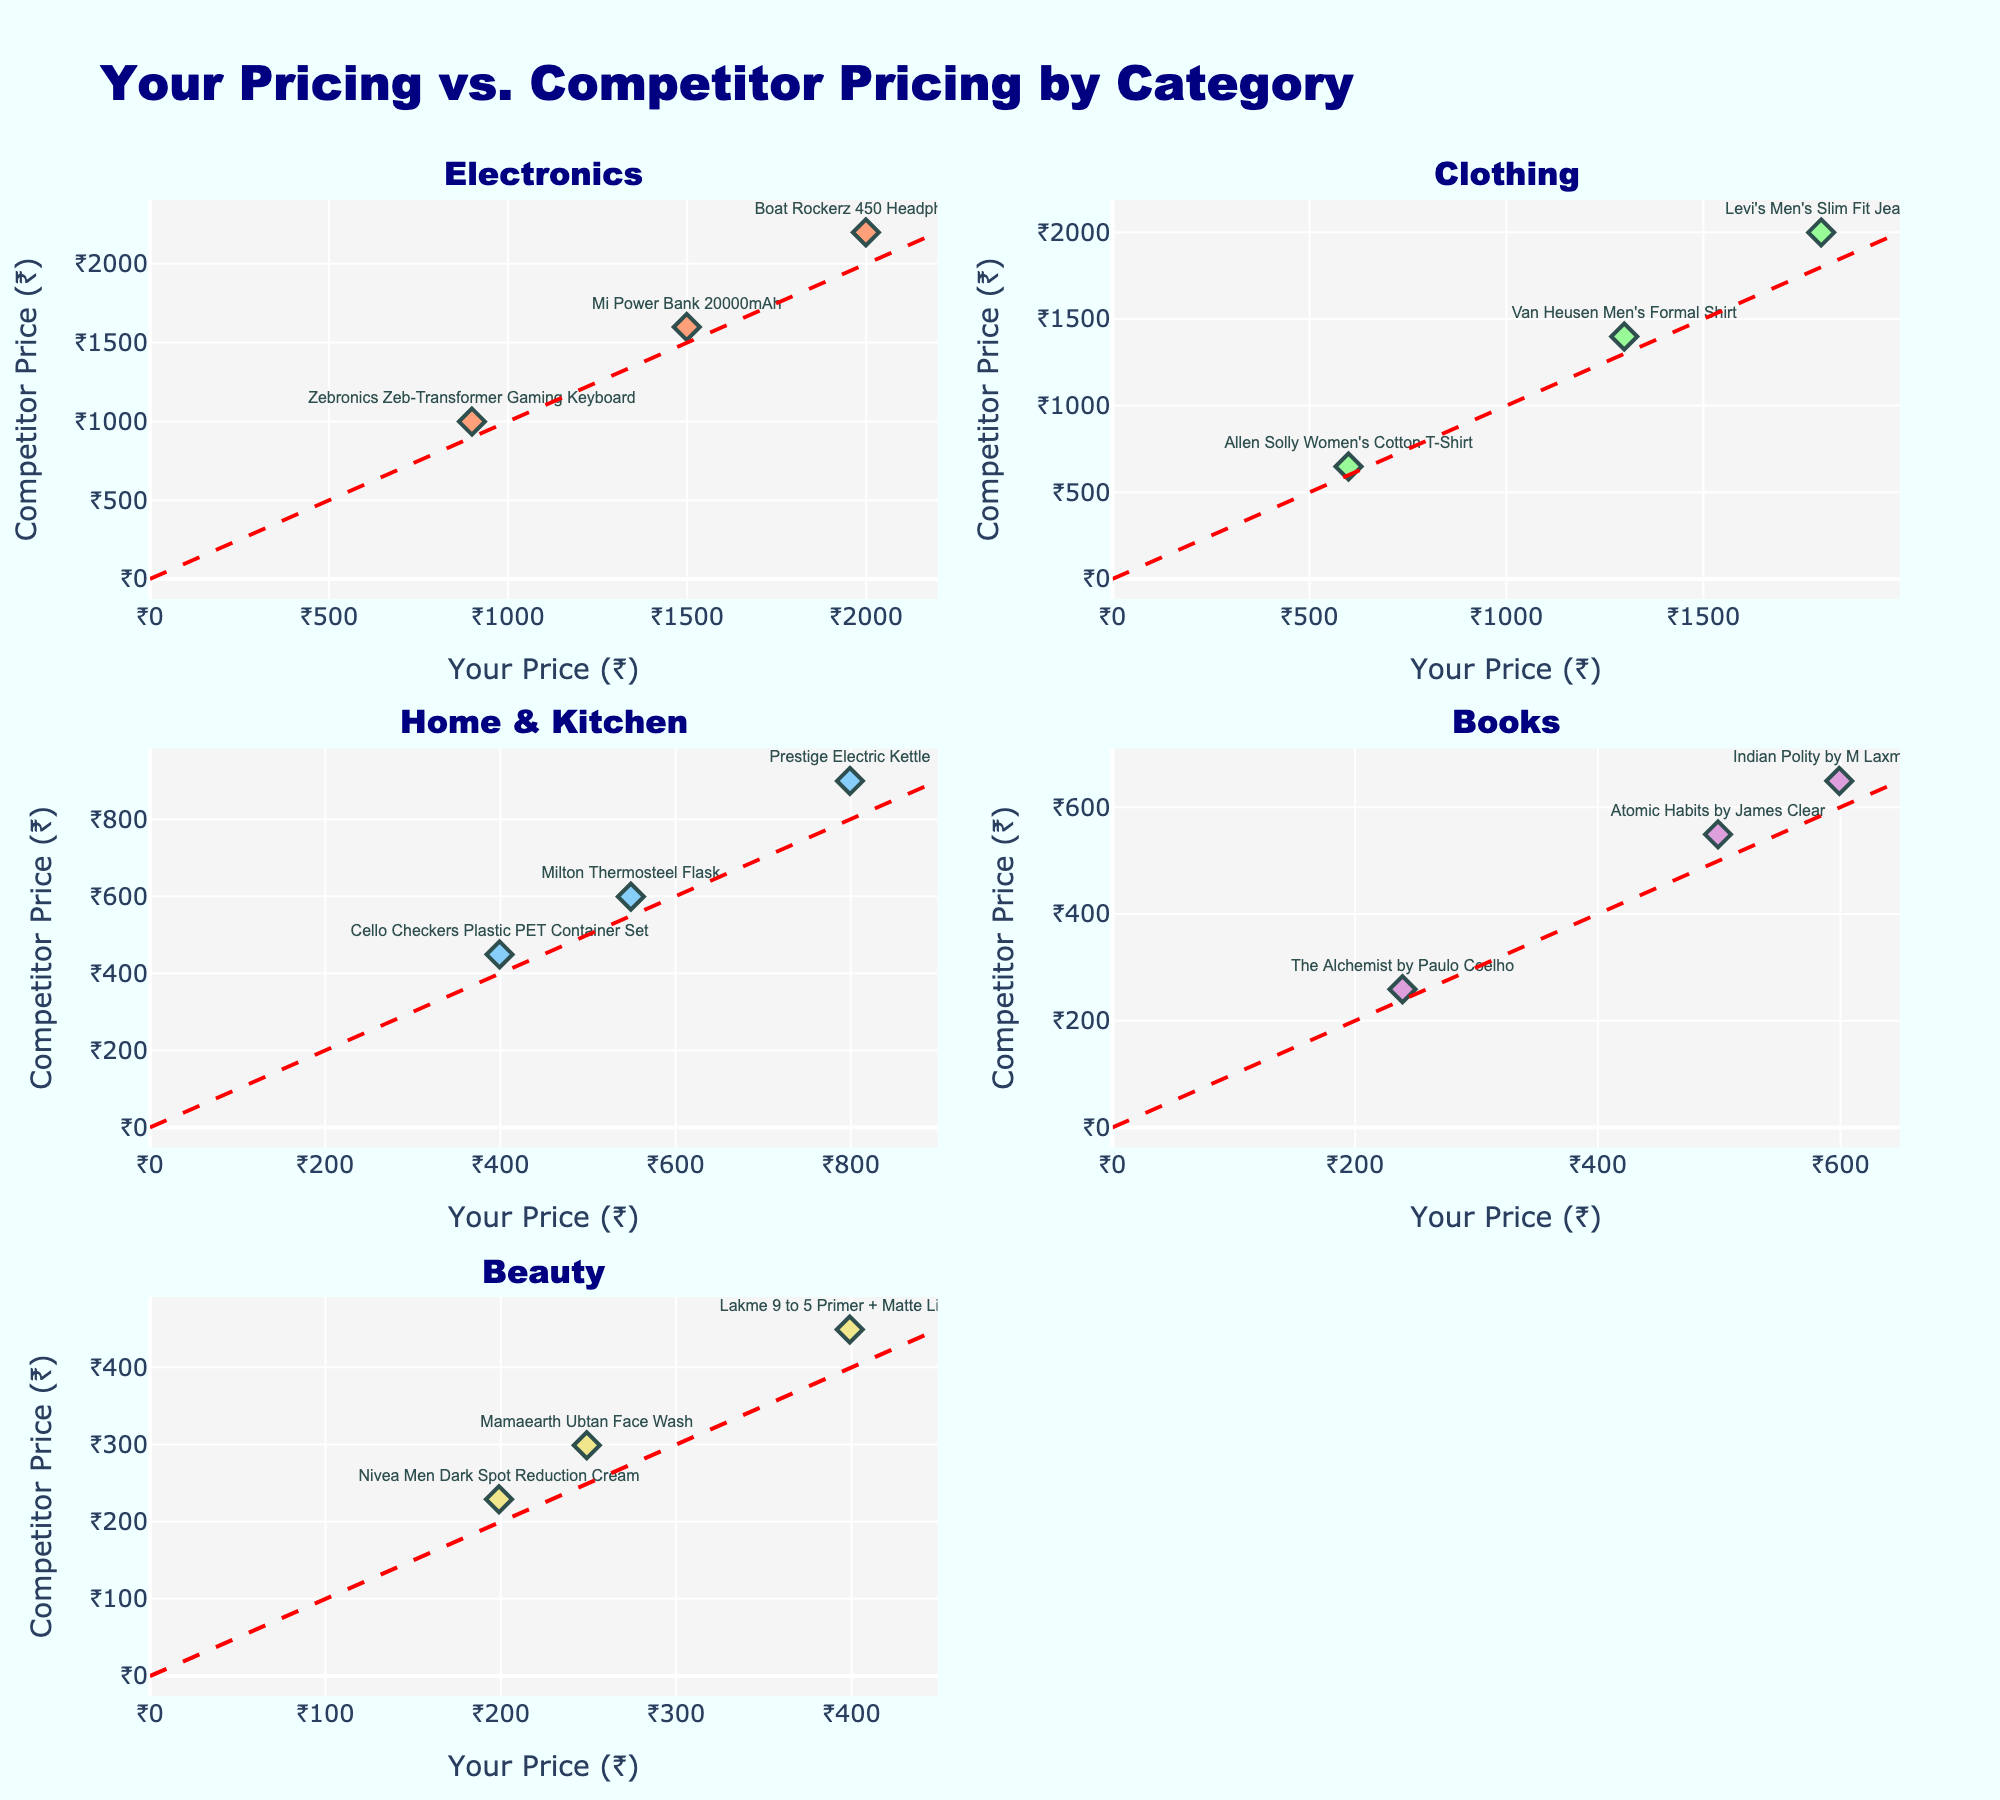What's the title of the figure? The title of the figure is located at the top and is clearly written in large bold text. From the visual, it states that the figure is about comparing your pricing with competitor pricing by category.
Answer: "Your Pricing vs. Competitor Pricing by Category" What's the relationship between the prices of "Boat Rockerz 450 Headphones" and "Mi Power Bank 20000mAh" in the Electronics category? To compare these two products, locate them in the Electronics subplot. The "Boat Rockerz 450 Headphones" has a lower price than the "Mi Power Bank 20000mAh" for both your pricing and the competitor's pricing.
Answer: The "Boat Rockerz 450 Headphones" have lower prices than "Mi Power Bank 20000mAh" in both your pricing and the competitor's pricing Which category has the widest price range in the plot? Look at the spread of points in each subplot (category). The Home & Kitchen category appears to have the widest spread in both your pricing and the competitor's pricing.
Answer: Home & Kitchen How many categories are there in the figure? Count the subplot titles as every subplot represents a different category. There are four titles: Electronics, Clothing, Home & Kitchen, Books, and Beauty.
Answer: 5 What color are the markers representing the Electronics category? In the subplot for Electronics, note the color of the markers which represent this category. The markers are colored in a specific shade that stands out.
Answer: Light Salmon Which product in the Home & Kitchen category has the smallest price difference between you and your competitor? Find the Home & Kitchen subplot. Examine each product and compare your price with the competitor's price. "Cello Checkers Plastic PET Container Set" has the smallest price difference.
Answer: "Cello Checkers Plastic PET Container Set" In the Beauty category, which product has the highest price according to your pricing? Locate the Beauty subplot. Among the products listed, "Lakme 9 to 5 Primer + Matte Lipstick" has the highest price in your pricing.
Answer: "Lakme 9 to 5 Primer + Matte Lipstick" What's the average price difference between your price and competitor's price for products in the Books category? Find the Books subplot and calculate the difference for each product (20 + 50 + 50). Then, average these differences by dividing by the number of products (3). The average price difference is (20 + 50 + 50) / 3 = 40.
Answer: 40 Are there any products where your price is higher than the competitor's price? Check each category. Compare the marker positions relative to the red dashed line (which represents equality). There are no products where your price exceeds the competitor's price.
Answer: No 